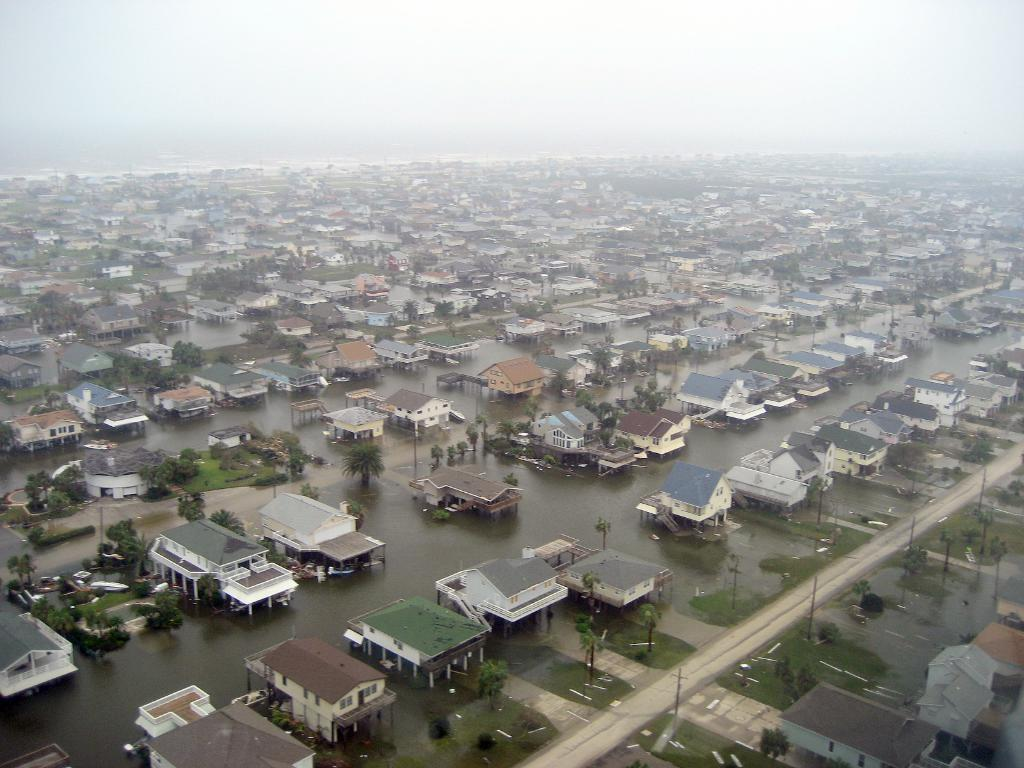What type of structures are visible in the image? There is a group of houses in the image. Are there any other houses visible besides the main group? Yes, houses are visible between the main group of houses. What else can be seen in the image besides houses? Roads and trees are visible in the image. What is visible at the top of the image? The sky is visible at the top of the image. What type of lace can be seen connecting the houses in the image? There is no lace connecting the houses in the image; the houses are separate structures. 